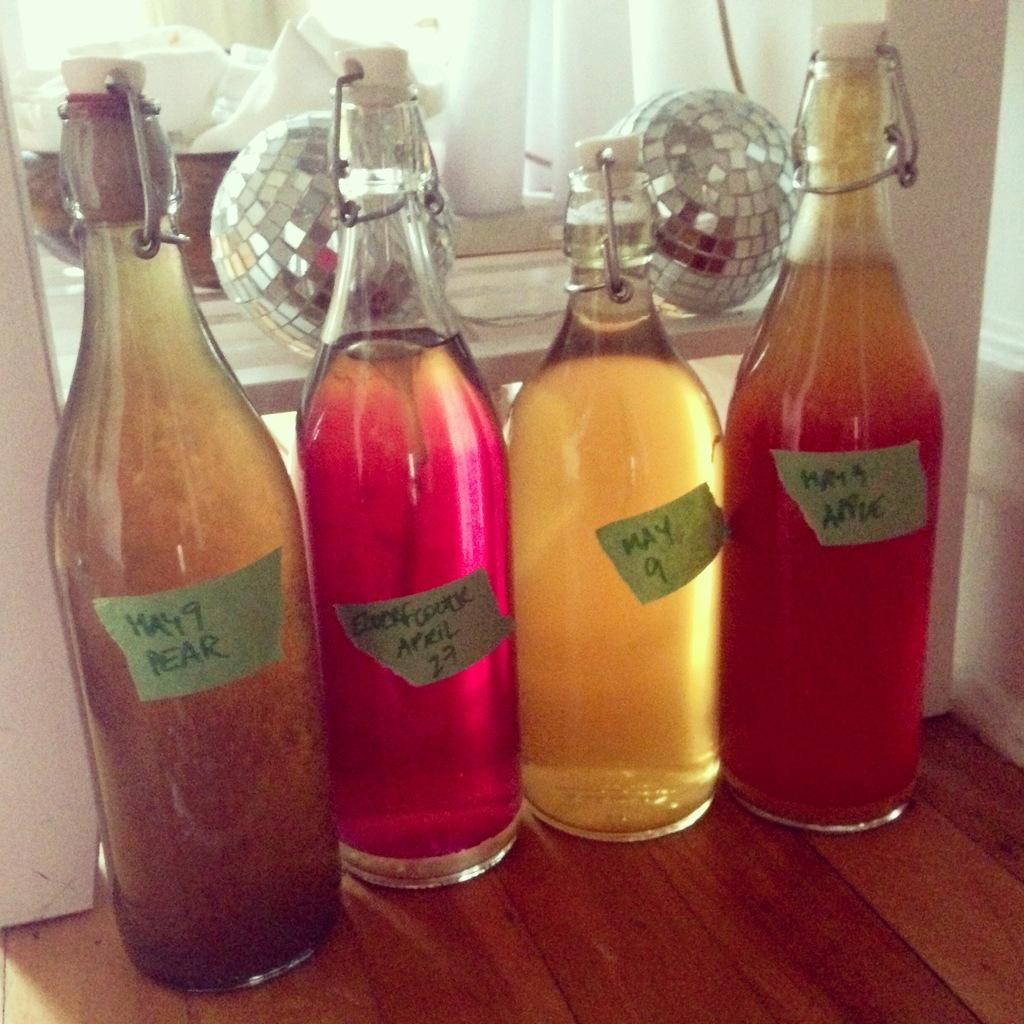<image>
Describe the image concisely. Four bottles sit in a row with post-it notes and the left note reads May 9 pear. 